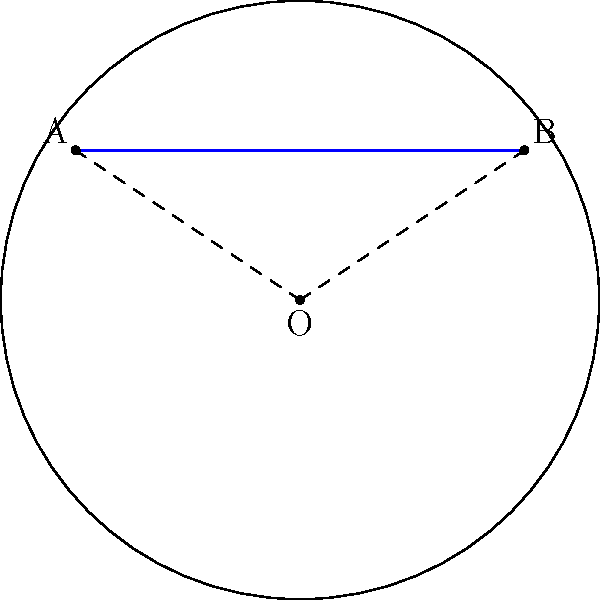In your cafe, you're organizing a community event with the local police department to discuss neighborhood safety. To illustrate a concept, you draw a diagram on a curved surface representing a hyperbolic plane. If points A and B represent two locations in the neighborhood, and the circle represents the edge of the visible universe in this model, what is the shape of the shortest path between A and B, and why isn't it a straight line? To understand the shortest path between two points on a hyperbolic plane, we need to follow these steps:

1. Recognize that in hyperbolic geometry, the shortest path between two points is a geodesic.

2. In the Poincaré disk model (which is what the diagram represents):
   a. The circle represents the edge of the visible universe.
   b. Straight lines in hyperbolic space are represented by either:
      - Arcs of circles that intersect the boundary circle at right angles
      - Diameters of the boundary circle

3. The blue curve in the diagram represents the geodesic between A and B.

4. This curve is not a straight line in the Euclidean sense because:
   a. In hyperbolic geometry, parallel lines diverge.
   b. The space is curved, causing straight lines to appear bent when represented in Euclidean space.

5. The geodesic minimizes the distance between A and B in hyperbolic space, even though it looks longer in the Euclidean representation.

6. This curved path is analogous to how airplanes fly in great circle routes on the spherical Earth, which appear curved on flat maps but are actually the shortest paths.

In the context of the community safety discussion, this could be used to illustrate how the most direct route between two locations might not always be what it seems, emphasizing the importance of local knowledge and community-police cooperation in understanding neighborhood dynamics.
Answer: The shortest path is a circular arc orthogonal to the boundary circle. 